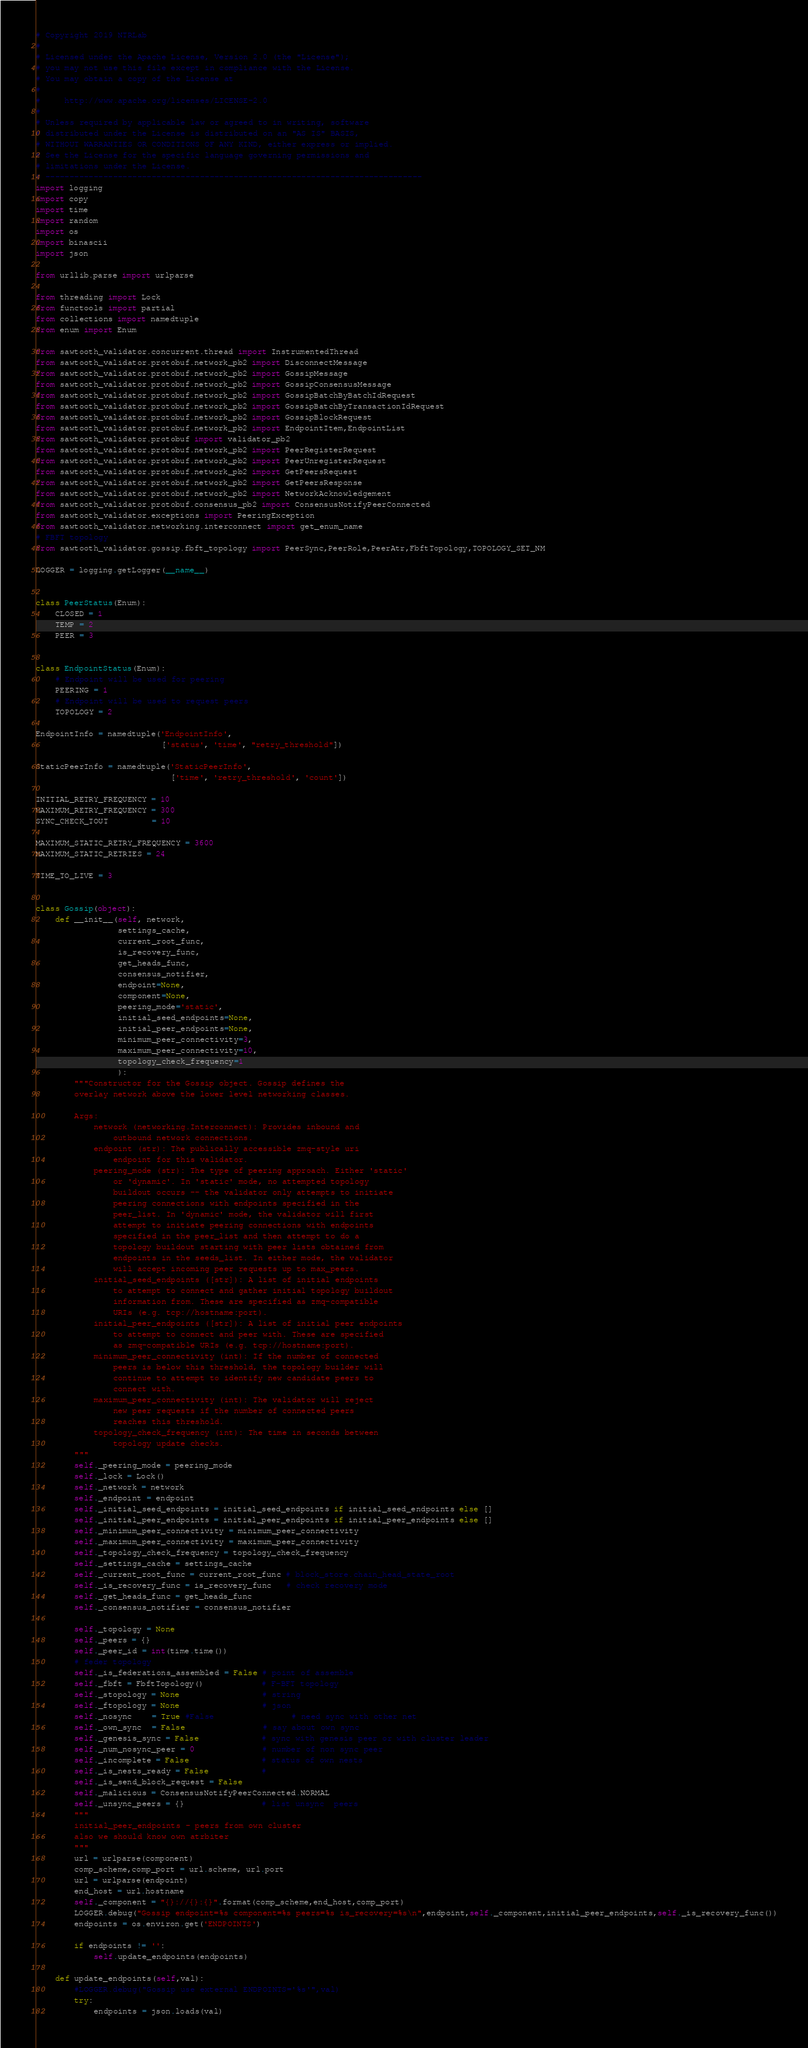Convert code to text. <code><loc_0><loc_0><loc_500><loc_500><_Python_># Copyright 2019 NTRLab
#
# Licensed under the Apache License, Version 2.0 (the "License");
# you may not use this file except in compliance with the License.
# You may obtain a copy of the License at
#
#     http://www.apache.org/licenses/LICENSE-2.0
#
# Unless required by applicable law or agreed to in writing, software
# distributed under the License is distributed on an "AS IS" BASIS,
# WITHOUT WARRANTIES OR CONDITIONS OF ANY KIND, either express or implied.
# See the License for the specific language governing permissions and
# limitations under the License.
# ------------------------------------------------------------------------------
import logging
import copy
import time
import random
import os
import binascii
import json

from urllib.parse import urlparse

from threading import Lock
from functools import partial
from collections import namedtuple
from enum import Enum

from sawtooth_validator.concurrent.thread import InstrumentedThread
from sawtooth_validator.protobuf.network_pb2 import DisconnectMessage
from sawtooth_validator.protobuf.network_pb2 import GossipMessage
from sawtooth_validator.protobuf.network_pb2 import GossipConsensusMessage
from sawtooth_validator.protobuf.network_pb2 import GossipBatchByBatchIdRequest
from sawtooth_validator.protobuf.network_pb2 import GossipBatchByTransactionIdRequest
from sawtooth_validator.protobuf.network_pb2 import GossipBlockRequest
from sawtooth_validator.protobuf.network_pb2 import EndpointItem,EndpointList
from sawtooth_validator.protobuf import validator_pb2
from sawtooth_validator.protobuf.network_pb2 import PeerRegisterRequest
from sawtooth_validator.protobuf.network_pb2 import PeerUnregisterRequest
from sawtooth_validator.protobuf.network_pb2 import GetPeersRequest
from sawtooth_validator.protobuf.network_pb2 import GetPeersResponse
from sawtooth_validator.protobuf.network_pb2 import NetworkAcknowledgement
from sawtooth_validator.protobuf.consensus_pb2 import ConsensusNotifyPeerConnected
from sawtooth_validator.exceptions import PeeringException
from sawtooth_validator.networking.interconnect import get_enum_name
# FBFT topology
from sawtooth_validator.gossip.fbft_topology import PeerSync,PeerRole,PeerAtr,FbftTopology,TOPOLOGY_SET_NM

LOGGER = logging.getLogger(__name__)


class PeerStatus(Enum):
    CLOSED = 1
    TEMP = 2
    PEER = 3


class EndpointStatus(Enum):
    # Endpoint will be used for peering
    PEERING = 1
    # Endpoint will be used to request peers
    TOPOLOGY = 2

EndpointInfo = namedtuple('EndpointInfo',
                          ['status', 'time', "retry_threshold"])

StaticPeerInfo = namedtuple('StaticPeerInfo',
                            ['time', 'retry_threshold', 'count'])

INITIAL_RETRY_FREQUENCY = 10
MAXIMUM_RETRY_FREQUENCY = 300
SYNC_CHECK_TOUT         = 10
   
MAXIMUM_STATIC_RETRY_FREQUENCY = 3600
MAXIMUM_STATIC_RETRIES = 24

TIME_TO_LIVE = 3


class Gossip(object):
    def __init__(self, network,
                 settings_cache,
                 current_root_func,
                 is_recovery_func,
                 get_heads_func,
                 consensus_notifier,
                 endpoint=None,
                 component=None,
                 peering_mode='static',
                 initial_seed_endpoints=None,
                 initial_peer_endpoints=None,
                 minimum_peer_connectivity=3,
                 maximum_peer_connectivity=10,
                 topology_check_frequency=1
                 ):
        """Constructor for the Gossip object. Gossip defines the
        overlay network above the lower level networking classes.

        Args:
            network (networking.Interconnect): Provides inbound and
                outbound network connections.
            endpoint (str): The publically accessible zmq-style uri
                endpoint for this validator.
            peering_mode (str): The type of peering approach. Either 'static'
                or 'dynamic'. In 'static' mode, no attempted topology
                buildout occurs -- the validator only attempts to initiate
                peering connections with endpoints specified in the
                peer_list. In 'dynamic' mode, the validator will first
                attempt to initiate peering connections with endpoints
                specified in the peer_list and then attempt to do a
                topology buildout starting with peer lists obtained from
                endpoints in the seeds_list. In either mode, the validator
                will accept incoming peer requests up to max_peers.
            initial_seed_endpoints ([str]): A list of initial endpoints
                to attempt to connect and gather initial topology buildout
                information from. These are specified as zmq-compatible
                URIs (e.g. tcp://hostname:port).
            initial_peer_endpoints ([str]): A list of initial peer endpoints
                to attempt to connect and peer with. These are specified
                as zmq-compatible URIs (e.g. tcp://hostname:port).
            minimum_peer_connectivity (int): If the number of connected
                peers is below this threshold, the topology builder will
                continue to attempt to identify new candidate peers to
                connect with.
            maximum_peer_connectivity (int): The validator will reject
                new peer requests if the number of connected peers
                reaches this threshold.
            topology_check_frequency (int): The time in seconds between
                topology update checks.
        """
        self._peering_mode = peering_mode
        self._lock = Lock()
        self._network = network
        self._endpoint = endpoint
        self._initial_seed_endpoints = initial_seed_endpoints if initial_seed_endpoints else []
        self._initial_peer_endpoints = initial_peer_endpoints if initial_peer_endpoints else []
        self._minimum_peer_connectivity = minimum_peer_connectivity
        self._maximum_peer_connectivity = maximum_peer_connectivity
        self._topology_check_frequency = topology_check_frequency
        self._settings_cache = settings_cache
        self._current_root_func = current_root_func # block_store.chain_head_state_root
        self._is_recovery_func = is_recovery_func   # check recovery mode
        self._get_heads_func = get_heads_func
        self._consensus_notifier = consensus_notifier

        self._topology = None
        self._peers = {}
        self._peer_id = int(time.time())
        # feder topology
        self._is_federations_assembled = False # point of assemble
        self._fbft = FbftTopology()            # F-BFT topology
        self._stopology = None                 # string 
        self._ftopology = None                 # json 
        self._nosync    = True #False                # need sync with other net 
        self._own_sync  = False                # say about own sync
        self._genesis_sync = False             # sync with genesis peer or with cluster leader
        self._num_nosync_peer = 0              # number of non sync peer 
        self._incomplete = False               # status of own nests 
        self._is_nests_ready = False           # 
        self._is_send_block_request = False
        self._malicious = ConsensusNotifyPeerConnected.NORMAL 
        self._unsync_peers = {}                # list unsync  peers
        """
        initial_peer_endpoints - peers from own cluster
        also we should know own atrbiter
        """
        url = urlparse(component)
        comp_scheme,comp_port = url.scheme, url.port
        url = urlparse(endpoint)
        end_host = url.hostname
        self._component = "{}://{}:{}".format(comp_scheme,end_host,comp_port)
        LOGGER.debug("Gossip endpoint=%s component=%s peers=%s is_recovery=%s\n",endpoint,self._component,initial_peer_endpoints,self._is_recovery_func())
        endpoints = os.environ.get('ENDPOINTS')
        
        if endpoints != '':
            self.update_endpoints(endpoints)

    def update_endpoints(self,val):
        #LOGGER.debug("Gossip use external ENDPOINTS='%s'",val)
        try:
            endpoints = json.loads(val)</code> 